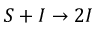Convert formula to latex. <formula><loc_0><loc_0><loc_500><loc_500>S + I { \rightarrow } 2 I</formula> 